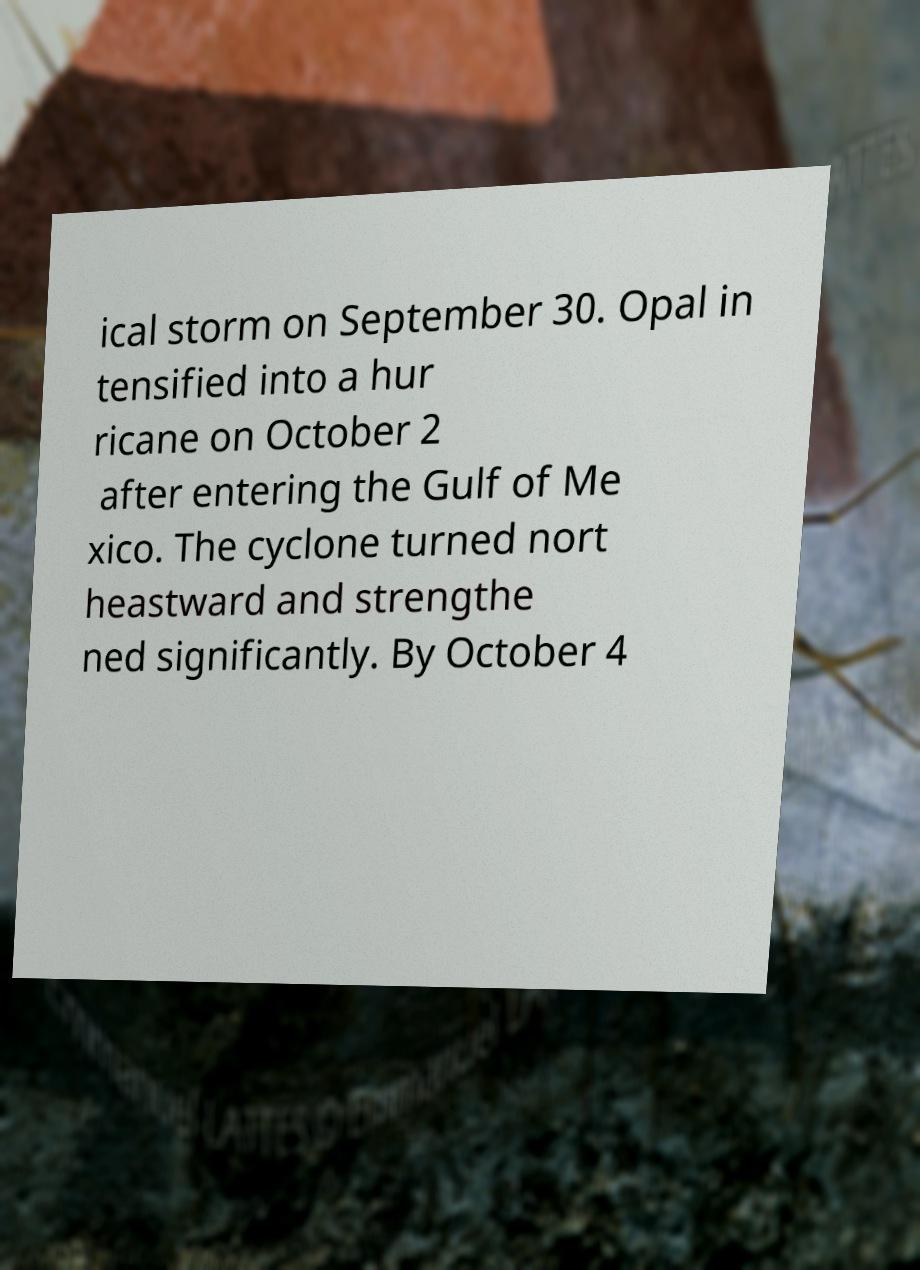Could you extract and type out the text from this image? ical storm on September 30. Opal in tensified into a hur ricane on October 2 after entering the Gulf of Me xico. The cyclone turned nort heastward and strengthe ned significantly. By October 4 